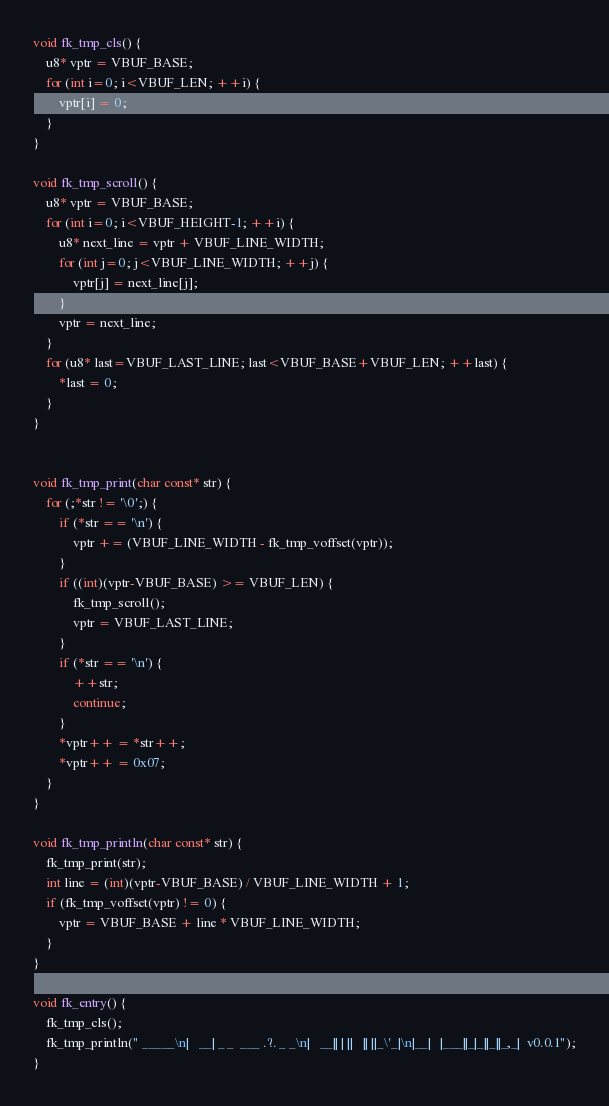<code> <loc_0><loc_0><loc_500><loc_500><_C_>
void fk_tmp_cls() {
    u8* vptr = VBUF_BASE;
    for (int i=0; i<VBUF_LEN; ++i) {
        vptr[i] = 0;
    }
}

void fk_tmp_scroll() {
    u8* vptr = VBUF_BASE;
    for (int i=0; i<VBUF_HEIGHT-1; ++i) {
        u8* next_line = vptr + VBUF_LINE_WIDTH;
        for (int j=0; j<VBUF_LINE_WIDTH; ++j) {
            vptr[j] = next_line[j];
        }
        vptr = next_line;
    }
    for (u8* last=VBUF_LAST_LINE; last<VBUF_BASE+VBUF_LEN; ++last) {
        *last = 0;
    }
}


void fk_tmp_print(char const* str) {
    for (;*str != '\0';) {
        if (*str == '\n') {
            vptr += (VBUF_LINE_WIDTH - fk_tmp_voffset(vptr));
        }
        if ((int)(vptr-VBUF_BASE) >= VBUF_LEN) {
            fk_tmp_scroll();
            vptr = VBUF_LAST_LINE;
        }
        if (*str == '\n') {
            ++str;
            continue;
        }
        *vptr++ = *str++;
        *vptr++ = 0x07;
    }
}

void fk_tmp_println(char const* str) {
    fk_tmp_print(str);
    int line = (int)(vptr-VBUF_BASE) / VBUF_LINE_WIDTH + 1;
    if (fk_tmp_voffset(vptr) != 0) {
        vptr = VBUF_BASE + line * VBUF_LINE_WIDTH;
    }
}

void fk_entry() {
    fk_tmp_cls();
    fk_tmp_println(" _____\n|   __| _ _  ___ .?. _ _\n|   __|| | ||   || ||_\'_|\n|__|   |___||_|_||_||_,_|  v0.0.1");
}

</code> 